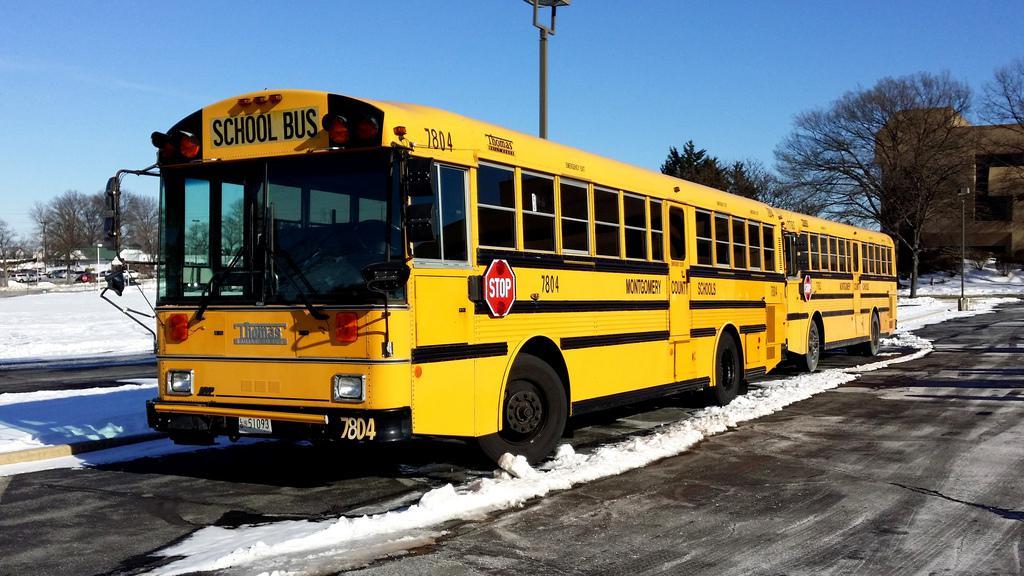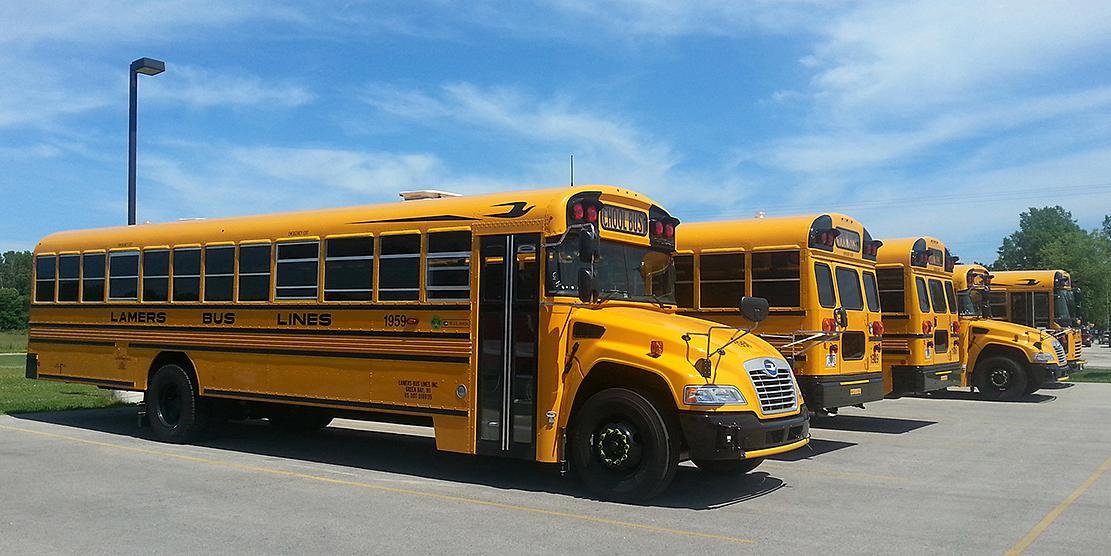The first image is the image on the left, the second image is the image on the right. Considering the images on both sides, is "A bus' passenger door is visible." valid? Answer yes or no. Yes. 